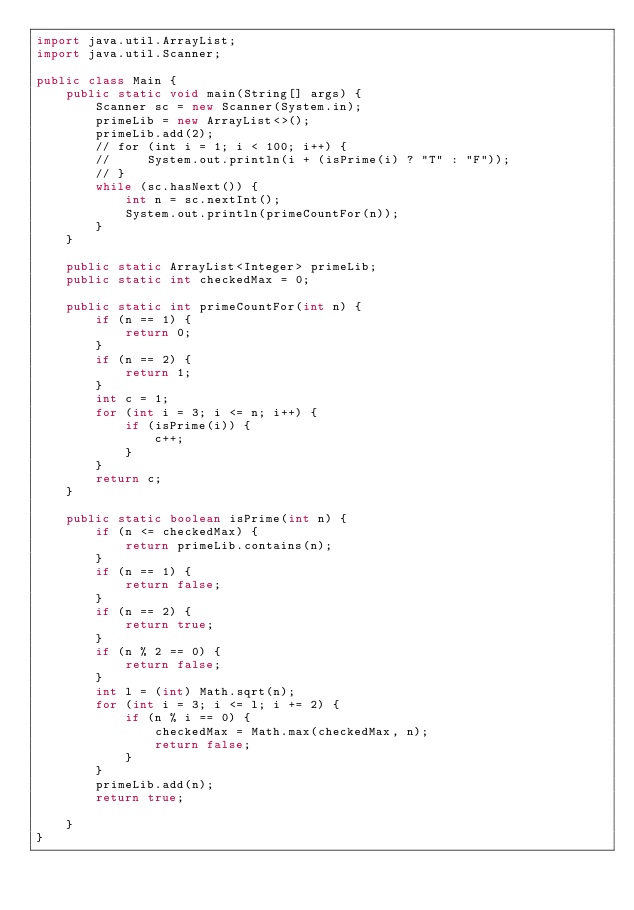<code> <loc_0><loc_0><loc_500><loc_500><_Java_>import java.util.ArrayList;
import java.util.Scanner;

public class Main {
    public static void main(String[] args) {
        Scanner sc = new Scanner(System.in);
        primeLib = new ArrayList<>();
        primeLib.add(2);
        // for (int i = 1; i < 100; i++) {
        //     System.out.println(i + (isPrime(i) ? "T" : "F"));
        // }
        while (sc.hasNext()) {
            int n = sc.nextInt();
            System.out.println(primeCountFor(n));
        }
    }

    public static ArrayList<Integer> primeLib;
    public static int checkedMax = 0;

    public static int primeCountFor(int n) {
        if (n == 1) {
            return 0;
        }
        if (n == 2) {
            return 1;
        }
        int c = 1;
        for (int i = 3; i <= n; i++) {
            if (isPrime(i)) {
                c++;
            }
        }
        return c;
    }

    public static boolean isPrime(int n) {
        if (n <= checkedMax) {
            return primeLib.contains(n);
        }
        if (n == 1) {
            return false;
        }
        if (n == 2) {
            return true;
        }
        if (n % 2 == 0) {
            return false;
        }
        int l = (int) Math.sqrt(n);
        for (int i = 3; i <= l; i += 2) {
            if (n % i == 0) {
                checkedMax = Math.max(checkedMax, n);
                return false;
            }
        }
        primeLib.add(n);
        return true;

    }
}</code> 